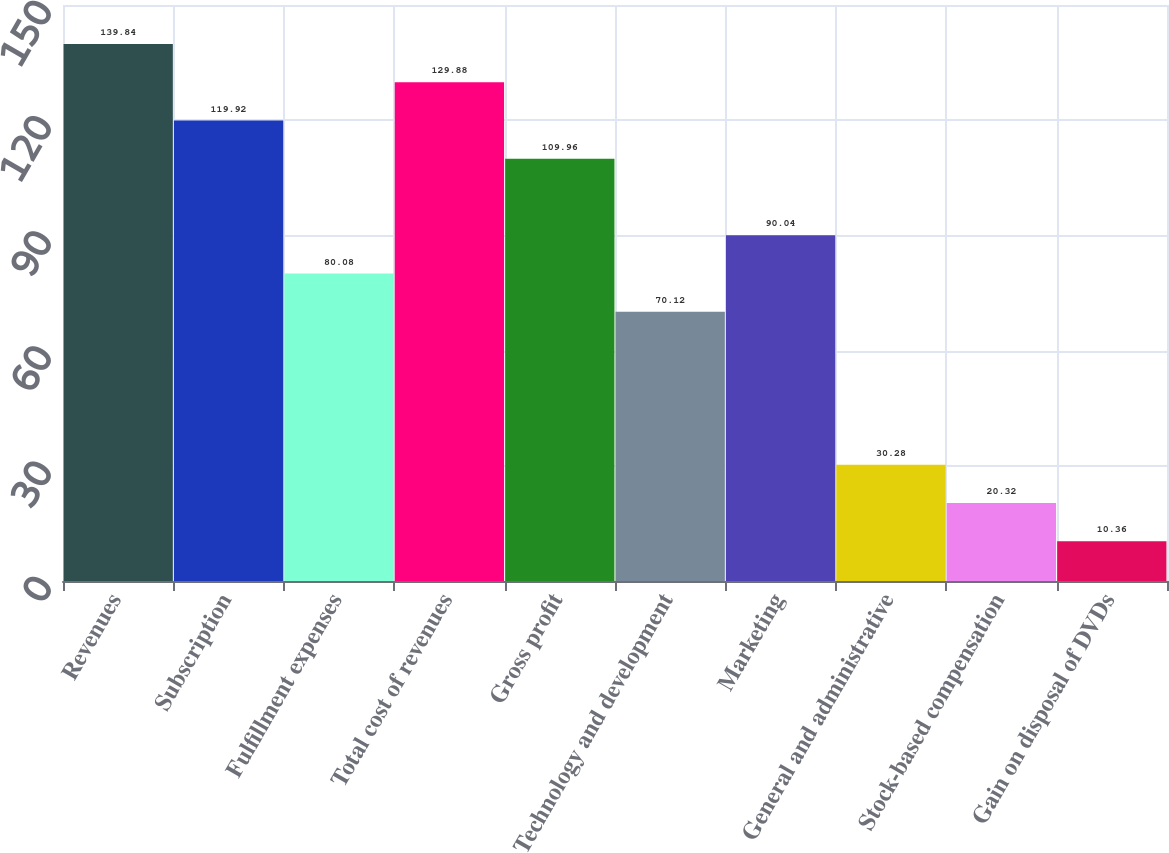<chart> <loc_0><loc_0><loc_500><loc_500><bar_chart><fcel>Revenues<fcel>Subscription<fcel>Fulfillment expenses<fcel>Total cost of revenues<fcel>Gross profit<fcel>Technology and development<fcel>Marketing<fcel>General and administrative<fcel>Stock-based compensation<fcel>Gain on disposal of DVDs<nl><fcel>139.84<fcel>119.92<fcel>80.08<fcel>129.88<fcel>109.96<fcel>70.12<fcel>90.04<fcel>30.28<fcel>20.32<fcel>10.36<nl></chart> 